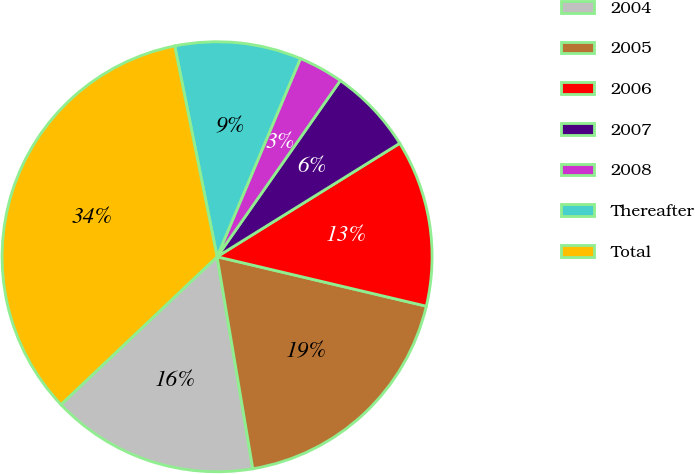<chart> <loc_0><loc_0><loc_500><loc_500><pie_chart><fcel>2004<fcel>2005<fcel>2006<fcel>2007<fcel>2008<fcel>Thereafter<fcel>Total<nl><fcel>15.59%<fcel>18.65%<fcel>12.54%<fcel>6.44%<fcel>3.38%<fcel>9.49%<fcel>33.91%<nl></chart> 